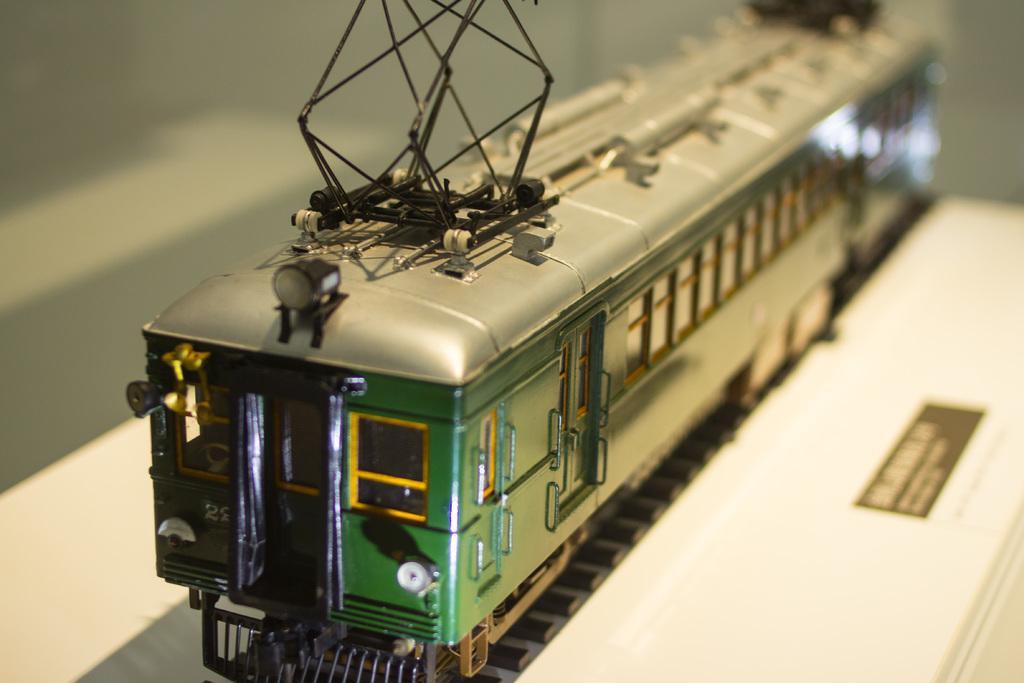How would you summarize this image in a sentence or two? In this image we can is a toy train on the track. 